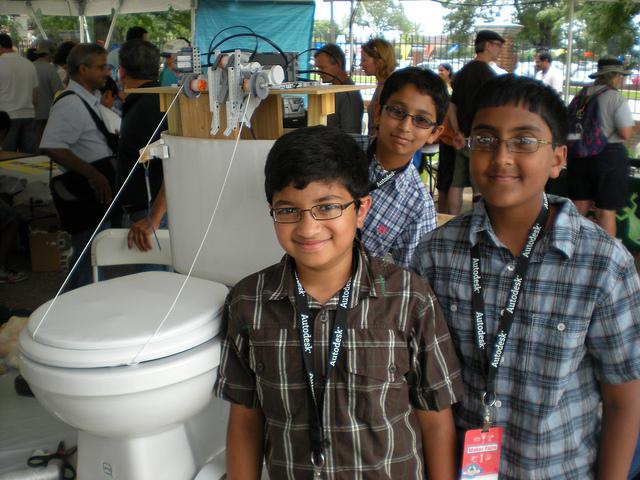What is beside the children?
Quick response, please. Toilet. What makes this toilet unique?
Give a very brief answer. Gadgetized. Is this toilet available to anyone who needs to use the bathroom?
Quick response, please. No. 